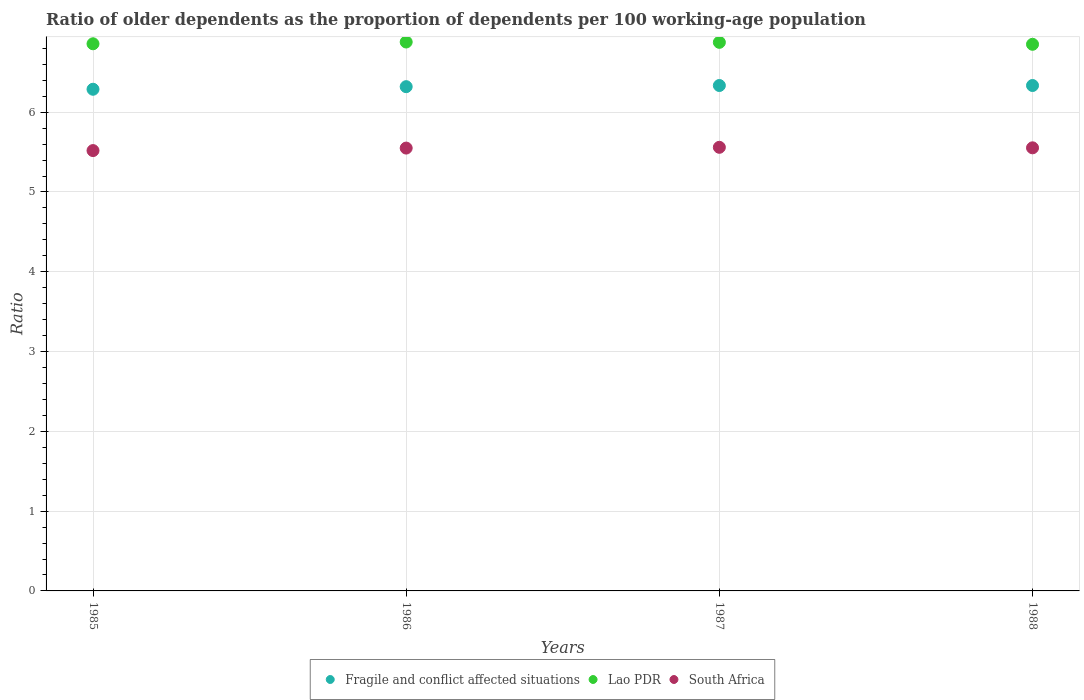How many different coloured dotlines are there?
Make the answer very short. 3. Is the number of dotlines equal to the number of legend labels?
Your answer should be very brief. Yes. What is the age dependency ratio(old) in Fragile and conflict affected situations in 1988?
Offer a very short reply. 6.33. Across all years, what is the maximum age dependency ratio(old) in Fragile and conflict affected situations?
Make the answer very short. 6.33. Across all years, what is the minimum age dependency ratio(old) in Fragile and conflict affected situations?
Keep it short and to the point. 6.29. In which year was the age dependency ratio(old) in Lao PDR maximum?
Your answer should be very brief. 1986. In which year was the age dependency ratio(old) in Lao PDR minimum?
Provide a succinct answer. 1988. What is the total age dependency ratio(old) in South Africa in the graph?
Your answer should be compact. 22.18. What is the difference between the age dependency ratio(old) in South Africa in 1987 and that in 1988?
Offer a terse response. 0.01. What is the difference between the age dependency ratio(old) in South Africa in 1988 and the age dependency ratio(old) in Fragile and conflict affected situations in 1987?
Give a very brief answer. -0.78. What is the average age dependency ratio(old) in Fragile and conflict affected situations per year?
Your answer should be compact. 6.32. In the year 1988, what is the difference between the age dependency ratio(old) in Fragile and conflict affected situations and age dependency ratio(old) in Lao PDR?
Provide a short and direct response. -0.52. In how many years, is the age dependency ratio(old) in South Africa greater than 5.6?
Provide a succinct answer. 0. What is the ratio of the age dependency ratio(old) in Fragile and conflict affected situations in 1985 to that in 1986?
Your answer should be compact. 0.99. Is the age dependency ratio(old) in South Africa in 1986 less than that in 1988?
Your answer should be compact. Yes. What is the difference between the highest and the second highest age dependency ratio(old) in Fragile and conflict affected situations?
Give a very brief answer. 2.5867686370695253e-5. What is the difference between the highest and the lowest age dependency ratio(old) in Lao PDR?
Provide a succinct answer. 0.03. Is it the case that in every year, the sum of the age dependency ratio(old) in South Africa and age dependency ratio(old) in Fragile and conflict affected situations  is greater than the age dependency ratio(old) in Lao PDR?
Make the answer very short. Yes. Is the age dependency ratio(old) in Fragile and conflict affected situations strictly greater than the age dependency ratio(old) in Lao PDR over the years?
Offer a very short reply. No. Is the age dependency ratio(old) in Fragile and conflict affected situations strictly less than the age dependency ratio(old) in Lao PDR over the years?
Your response must be concise. Yes. How many dotlines are there?
Ensure brevity in your answer.  3. How many years are there in the graph?
Make the answer very short. 4. Does the graph contain any zero values?
Provide a succinct answer. No. Where does the legend appear in the graph?
Offer a terse response. Bottom center. How many legend labels are there?
Offer a terse response. 3. What is the title of the graph?
Ensure brevity in your answer.  Ratio of older dependents as the proportion of dependents per 100 working-age population. What is the label or title of the Y-axis?
Offer a terse response. Ratio. What is the Ratio in Fragile and conflict affected situations in 1985?
Offer a very short reply. 6.29. What is the Ratio in Lao PDR in 1985?
Offer a terse response. 6.86. What is the Ratio of South Africa in 1985?
Keep it short and to the point. 5.52. What is the Ratio in Fragile and conflict affected situations in 1986?
Your response must be concise. 6.32. What is the Ratio in Lao PDR in 1986?
Give a very brief answer. 6.88. What is the Ratio in South Africa in 1986?
Provide a short and direct response. 5.55. What is the Ratio of Fragile and conflict affected situations in 1987?
Ensure brevity in your answer.  6.33. What is the Ratio of Lao PDR in 1987?
Ensure brevity in your answer.  6.88. What is the Ratio of South Africa in 1987?
Keep it short and to the point. 5.56. What is the Ratio of Fragile and conflict affected situations in 1988?
Your response must be concise. 6.33. What is the Ratio in Lao PDR in 1988?
Your answer should be very brief. 6.85. What is the Ratio of South Africa in 1988?
Provide a short and direct response. 5.55. Across all years, what is the maximum Ratio of Fragile and conflict affected situations?
Provide a short and direct response. 6.33. Across all years, what is the maximum Ratio of Lao PDR?
Provide a short and direct response. 6.88. Across all years, what is the maximum Ratio in South Africa?
Provide a short and direct response. 5.56. Across all years, what is the minimum Ratio in Fragile and conflict affected situations?
Make the answer very short. 6.29. Across all years, what is the minimum Ratio in Lao PDR?
Your answer should be compact. 6.85. Across all years, what is the minimum Ratio in South Africa?
Provide a short and direct response. 5.52. What is the total Ratio in Fragile and conflict affected situations in the graph?
Your answer should be compact. 25.28. What is the total Ratio of Lao PDR in the graph?
Offer a very short reply. 27.46. What is the total Ratio in South Africa in the graph?
Your answer should be compact. 22.18. What is the difference between the Ratio in Fragile and conflict affected situations in 1985 and that in 1986?
Offer a very short reply. -0.03. What is the difference between the Ratio in Lao PDR in 1985 and that in 1986?
Your answer should be very brief. -0.02. What is the difference between the Ratio in South Africa in 1985 and that in 1986?
Provide a succinct answer. -0.03. What is the difference between the Ratio of Fragile and conflict affected situations in 1985 and that in 1987?
Provide a succinct answer. -0.05. What is the difference between the Ratio of Lao PDR in 1985 and that in 1987?
Ensure brevity in your answer.  -0.02. What is the difference between the Ratio in South Africa in 1985 and that in 1987?
Keep it short and to the point. -0.04. What is the difference between the Ratio in Fragile and conflict affected situations in 1985 and that in 1988?
Ensure brevity in your answer.  -0.05. What is the difference between the Ratio of Lao PDR in 1985 and that in 1988?
Make the answer very short. 0.01. What is the difference between the Ratio of South Africa in 1985 and that in 1988?
Keep it short and to the point. -0.03. What is the difference between the Ratio of Fragile and conflict affected situations in 1986 and that in 1987?
Your answer should be compact. -0.01. What is the difference between the Ratio in Lao PDR in 1986 and that in 1987?
Offer a terse response. 0. What is the difference between the Ratio in South Africa in 1986 and that in 1987?
Your answer should be very brief. -0.01. What is the difference between the Ratio of Fragile and conflict affected situations in 1986 and that in 1988?
Make the answer very short. -0.01. What is the difference between the Ratio of Lao PDR in 1986 and that in 1988?
Your answer should be very brief. 0.03. What is the difference between the Ratio in South Africa in 1986 and that in 1988?
Make the answer very short. -0. What is the difference between the Ratio of Lao PDR in 1987 and that in 1988?
Your response must be concise. 0.02. What is the difference between the Ratio in South Africa in 1987 and that in 1988?
Ensure brevity in your answer.  0.01. What is the difference between the Ratio in Fragile and conflict affected situations in 1985 and the Ratio in Lao PDR in 1986?
Keep it short and to the point. -0.59. What is the difference between the Ratio in Fragile and conflict affected situations in 1985 and the Ratio in South Africa in 1986?
Offer a terse response. 0.74. What is the difference between the Ratio in Lao PDR in 1985 and the Ratio in South Africa in 1986?
Your answer should be compact. 1.31. What is the difference between the Ratio in Fragile and conflict affected situations in 1985 and the Ratio in Lao PDR in 1987?
Give a very brief answer. -0.59. What is the difference between the Ratio in Fragile and conflict affected situations in 1985 and the Ratio in South Africa in 1987?
Offer a terse response. 0.73. What is the difference between the Ratio of Lao PDR in 1985 and the Ratio of South Africa in 1987?
Provide a short and direct response. 1.3. What is the difference between the Ratio of Fragile and conflict affected situations in 1985 and the Ratio of Lao PDR in 1988?
Offer a very short reply. -0.56. What is the difference between the Ratio of Fragile and conflict affected situations in 1985 and the Ratio of South Africa in 1988?
Make the answer very short. 0.73. What is the difference between the Ratio in Lao PDR in 1985 and the Ratio in South Africa in 1988?
Your response must be concise. 1.3. What is the difference between the Ratio of Fragile and conflict affected situations in 1986 and the Ratio of Lao PDR in 1987?
Your answer should be compact. -0.56. What is the difference between the Ratio of Fragile and conflict affected situations in 1986 and the Ratio of South Africa in 1987?
Give a very brief answer. 0.76. What is the difference between the Ratio in Lao PDR in 1986 and the Ratio in South Africa in 1987?
Give a very brief answer. 1.32. What is the difference between the Ratio in Fragile and conflict affected situations in 1986 and the Ratio in Lao PDR in 1988?
Keep it short and to the point. -0.53. What is the difference between the Ratio of Fragile and conflict affected situations in 1986 and the Ratio of South Africa in 1988?
Provide a succinct answer. 0.77. What is the difference between the Ratio of Lao PDR in 1986 and the Ratio of South Africa in 1988?
Make the answer very short. 1.33. What is the difference between the Ratio in Fragile and conflict affected situations in 1987 and the Ratio in Lao PDR in 1988?
Offer a terse response. -0.52. What is the difference between the Ratio of Fragile and conflict affected situations in 1987 and the Ratio of South Africa in 1988?
Keep it short and to the point. 0.78. What is the difference between the Ratio of Lao PDR in 1987 and the Ratio of South Africa in 1988?
Make the answer very short. 1.32. What is the average Ratio of Fragile and conflict affected situations per year?
Keep it short and to the point. 6.32. What is the average Ratio in Lao PDR per year?
Your answer should be very brief. 6.87. What is the average Ratio in South Africa per year?
Your answer should be compact. 5.55. In the year 1985, what is the difference between the Ratio of Fragile and conflict affected situations and Ratio of Lao PDR?
Offer a terse response. -0.57. In the year 1985, what is the difference between the Ratio of Fragile and conflict affected situations and Ratio of South Africa?
Your answer should be very brief. 0.77. In the year 1985, what is the difference between the Ratio of Lao PDR and Ratio of South Africa?
Offer a very short reply. 1.34. In the year 1986, what is the difference between the Ratio in Fragile and conflict affected situations and Ratio in Lao PDR?
Offer a terse response. -0.56. In the year 1986, what is the difference between the Ratio in Fragile and conflict affected situations and Ratio in South Africa?
Your answer should be compact. 0.77. In the year 1986, what is the difference between the Ratio of Lao PDR and Ratio of South Africa?
Offer a very short reply. 1.33. In the year 1987, what is the difference between the Ratio of Fragile and conflict affected situations and Ratio of Lao PDR?
Your answer should be very brief. -0.54. In the year 1987, what is the difference between the Ratio of Fragile and conflict affected situations and Ratio of South Africa?
Provide a succinct answer. 0.77. In the year 1987, what is the difference between the Ratio in Lao PDR and Ratio in South Africa?
Give a very brief answer. 1.32. In the year 1988, what is the difference between the Ratio of Fragile and conflict affected situations and Ratio of Lao PDR?
Your answer should be very brief. -0.52. In the year 1988, what is the difference between the Ratio of Fragile and conflict affected situations and Ratio of South Africa?
Make the answer very short. 0.78. In the year 1988, what is the difference between the Ratio of Lao PDR and Ratio of South Africa?
Make the answer very short. 1.3. What is the ratio of the Ratio in Fragile and conflict affected situations in 1985 to that in 1987?
Give a very brief answer. 0.99. What is the ratio of the Ratio of Lao PDR in 1985 to that in 1988?
Make the answer very short. 1. What is the ratio of the Ratio in Lao PDR in 1986 to that in 1987?
Make the answer very short. 1. What is the ratio of the Ratio in South Africa in 1986 to that in 1987?
Provide a short and direct response. 1. What is the ratio of the Ratio in Lao PDR in 1986 to that in 1988?
Offer a very short reply. 1. What is the ratio of the Ratio of South Africa in 1986 to that in 1988?
Provide a succinct answer. 1. What is the ratio of the Ratio of Fragile and conflict affected situations in 1987 to that in 1988?
Ensure brevity in your answer.  1. What is the ratio of the Ratio of South Africa in 1987 to that in 1988?
Your response must be concise. 1. What is the difference between the highest and the second highest Ratio in Lao PDR?
Your answer should be very brief. 0. What is the difference between the highest and the second highest Ratio of South Africa?
Offer a terse response. 0.01. What is the difference between the highest and the lowest Ratio of Fragile and conflict affected situations?
Your answer should be compact. 0.05. What is the difference between the highest and the lowest Ratio of Lao PDR?
Keep it short and to the point. 0.03. What is the difference between the highest and the lowest Ratio in South Africa?
Your answer should be compact. 0.04. 